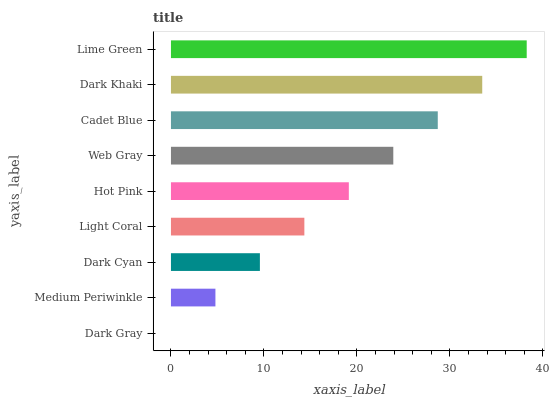Is Dark Gray the minimum?
Answer yes or no. Yes. Is Lime Green the maximum?
Answer yes or no. Yes. Is Medium Periwinkle the minimum?
Answer yes or no. No. Is Medium Periwinkle the maximum?
Answer yes or no. No. Is Medium Periwinkle greater than Dark Gray?
Answer yes or no. Yes. Is Dark Gray less than Medium Periwinkle?
Answer yes or no. Yes. Is Dark Gray greater than Medium Periwinkle?
Answer yes or no. No. Is Medium Periwinkle less than Dark Gray?
Answer yes or no. No. Is Hot Pink the high median?
Answer yes or no. Yes. Is Hot Pink the low median?
Answer yes or no. Yes. Is Medium Periwinkle the high median?
Answer yes or no. No. Is Web Gray the low median?
Answer yes or no. No. 